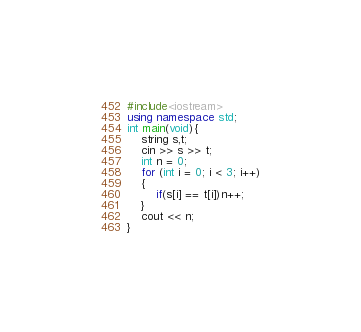Convert code to text. <code><loc_0><loc_0><loc_500><loc_500><_C++_>#include<iostream>
using namespace std;
int main(void){
    string s,t;
    cin >> s >> t;
    int n = 0;
    for (int i = 0; i < 3; i++)
    {
        if(s[i] == t[i])n++;
    }
    cout << n;
}
</code> 